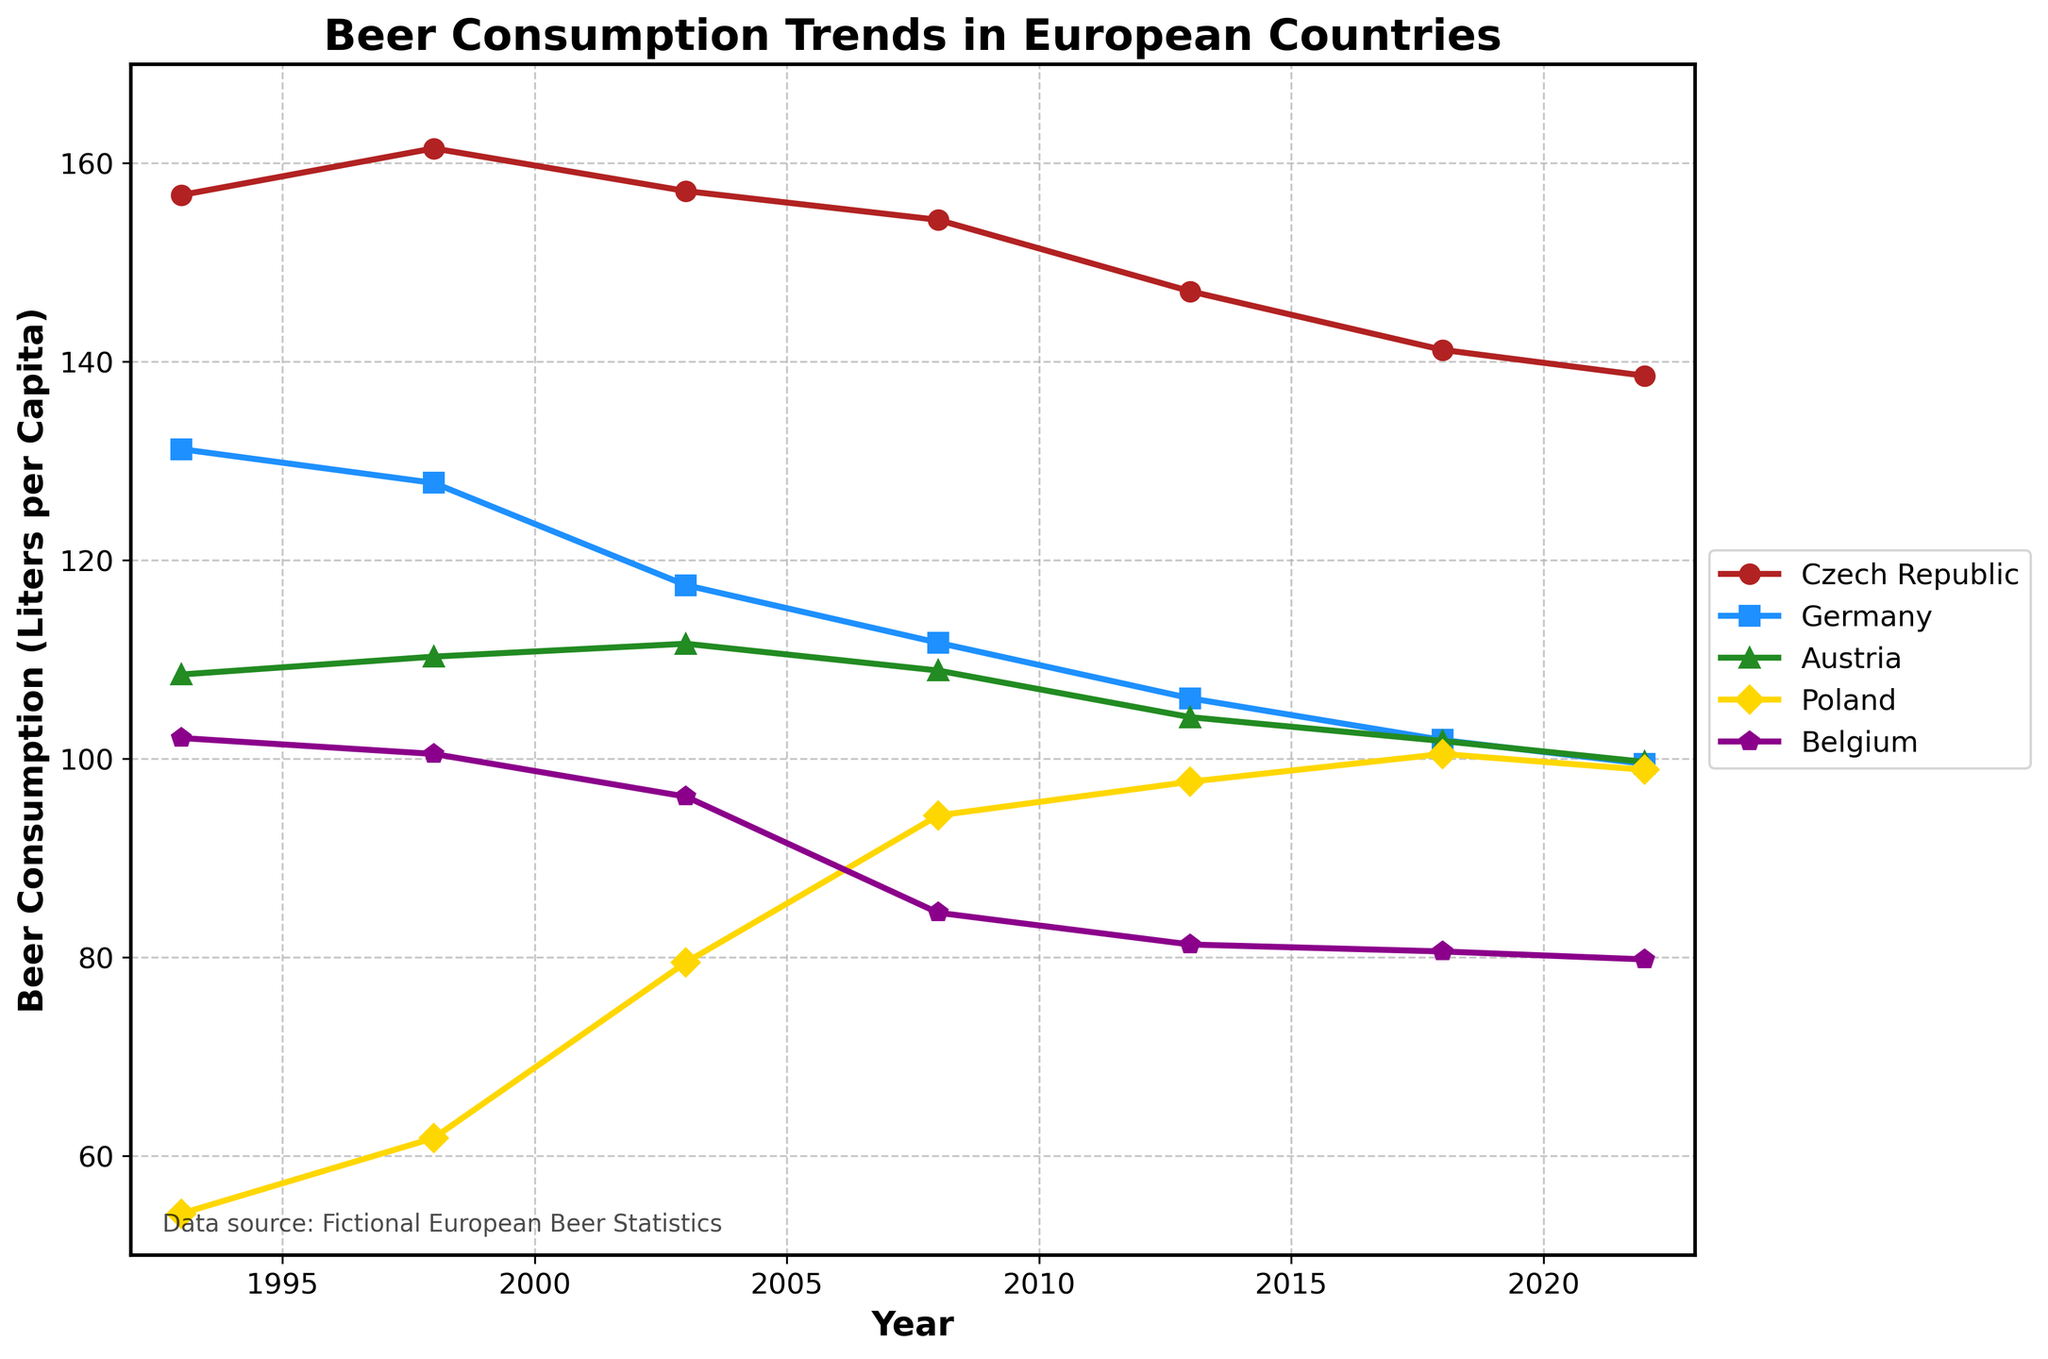What's the trend for beer consumption in the Czech Republic from 1993 to 2022? To find the trend, observe the Czech Republic's line from 1993 to 2022. It starts at 156.8 liters in 1993 and gradually decreases to 138.6 liters in 2022. Thus, the trend is a decreasing one.
Answer: Decreasing Which country had the highest beer consumption per capita in 2022? Look at the data points for 2022. The Czech Republic has 138.6 liters, Germany has 99.5 liters, Austria has 99.7 liters, Poland has 98.9 liters, and Belgium has 79.8 liters. The Czech Republic has the highest consumption.
Answer: Czech Republic Between which years did Poland show the most significant increase in beer consumption per capita? Examine the data points for Poland. From 1993 to 1998 (54.2 to 61.8), from 1998 to 2003 (61.8 to 79.5), from 2003 to 2008 (79.5 to 94.3), from 2008 to 2013 (94.3 to 97.7), and from 2013 to 2018 (97.7 to 100.5). The most significant increase is between 2003 and 2008.
Answer: 2003 to 2008 How does Belgium’s beer consumption in 2018 compare to its consumption in 1993? Belgium's consumption in 1993 is 102.1 liters, and in 2018, it's 80.6 liters. To compare, subtract 80.6 from 102.1, showing a decrease of 21.5 liters.
Answer: 21.5 liters decrease By how much did Germany's beer consumption per capita decrease from 1993 to 2022? In 1993, Germany's consumption was 131.2 liters, and in 2022, it was 99.5 liters. The decrease is 131.2 - 99.5, which equals 31.7 liters.
Answer: 31.7 liters Which two countries’ beer consumption trends are the most similar over the given period? Visually compare the trend lines in the figure. Germany and Austria have similar downward trends, both starting high and declining regularly.
Answer: Germany and Austria In which year was the beer consumption in Austria closest to that of Poland? Compare the data points for each year. In 2018, Austria had 101.8 liters and Poland had 100.5 liters. The difference is the smallest at 1.3 liters.
Answer: 2018 What is the average beer consumption in Belgium over the entire period? Sum Belgium’s consumption from 1993 to 2022 (102.1 + 100.5 + 96.2 + 84.5 + 81.3 + 80.6 + 79.8) and divide by 7: (102.1 + 100.5 + 96.2 + 84.5 + 81.3 + 80.6 + 79.8) / 7 = 89.28 liters.
Answer: 89.28 liters Which country experienced the least variation in beer consumption per capita over the given years? Visually inspect the lines for each country for stability, Austria's line appears the most stable compared to the fluctuating lines of other countries.
Answer: Austria What is the combined beer consumption per capita of the Czech Republic and Germany in 1993? Add the consumption values of Czech Republic and Germany for 1993: 156.8 + 131.2 = 288 liters.
Answer: 288 liters 